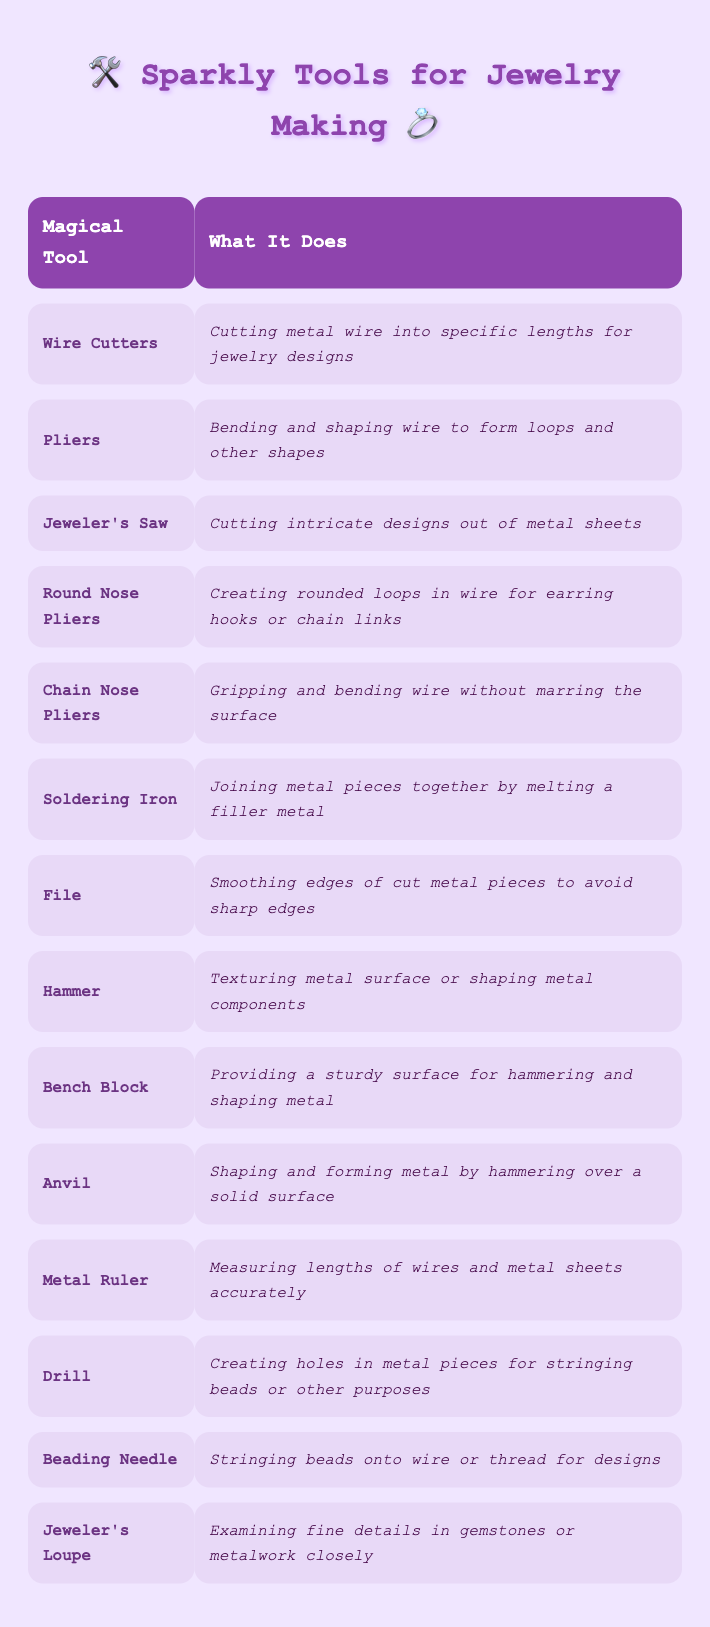What is one use of Wire Cutters? Wire Cutters' usage scenario is mentioned in the table as "Cutting metal wire into specific lengths for jewelry designs," so you can refer directly to that row.
Answer: Cutting metal wire into specific lengths for jewelry designs Which tool is used for creating holes in metal pieces? The table indicates that the Drill is used for "Creating holes in metal pieces for stringing beads or other purposes," giving us the direct answer.
Answer: Drill Is it true that Round Nose Pliers can be used for making rounded loops? The usage scenario for Round Nose Pliers in the table states, "Creating rounded loops in wire for earring hooks or chain links," confirming its functionality related to rounded loops.
Answer: Yes How many tools mentioned in the table specifically involve bending or shaping metal? By examining the table, we find four tools related to bending or shaping: Pliers, Round Nose Pliers, Chain Nose Pliers, and Hammer. Therefore, there are four tools.
Answer: 4 What tool would you use to smooth sharp edges on cut metal pieces? The table shows that the File is designated for "Smoothing edges of cut metal pieces to avoid sharp edges," making it the appropriate tool for this task.
Answer: File Which tool is primarily used for measuring lengths accurately? The table defines that the Metal Ruler is responsible for "Measuring lengths of wires and metal sheets accurately," so this directly answers the question.
Answer: Metal Ruler If you need to join two pieces of metal together, which tool would you choose? According to the table, the Soldering Iron is the tool used for "Joining metal pieces together by melting a filler metal," making it the correct choice for this task.
Answer: Soldering Iron What are two tools used for hammering or shaping metal? Looking at the table, we identify the Hammer and the Anvil are both tools for shaping metal, as their usage scenarios mention texturing or shaping through hammering.
Answer: Hammer and Anvil Among the mentioned tools, which one is used for examining details closely? The table indicates that the Jeweler's Loupe is specifically used for "Examining fine details in gemstones or metalwork closely," providing the clear answer.
Answer: Jeweler's Loupe 